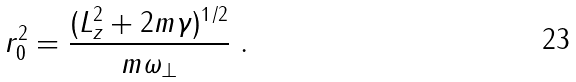Convert formula to latex. <formula><loc_0><loc_0><loc_500><loc_500>r _ { 0 } ^ { 2 } = \frac { ( L _ { z } ^ { 2 } + 2 m \gamma ) ^ { 1 / 2 } } { m \omega _ { \perp } } \ .</formula> 